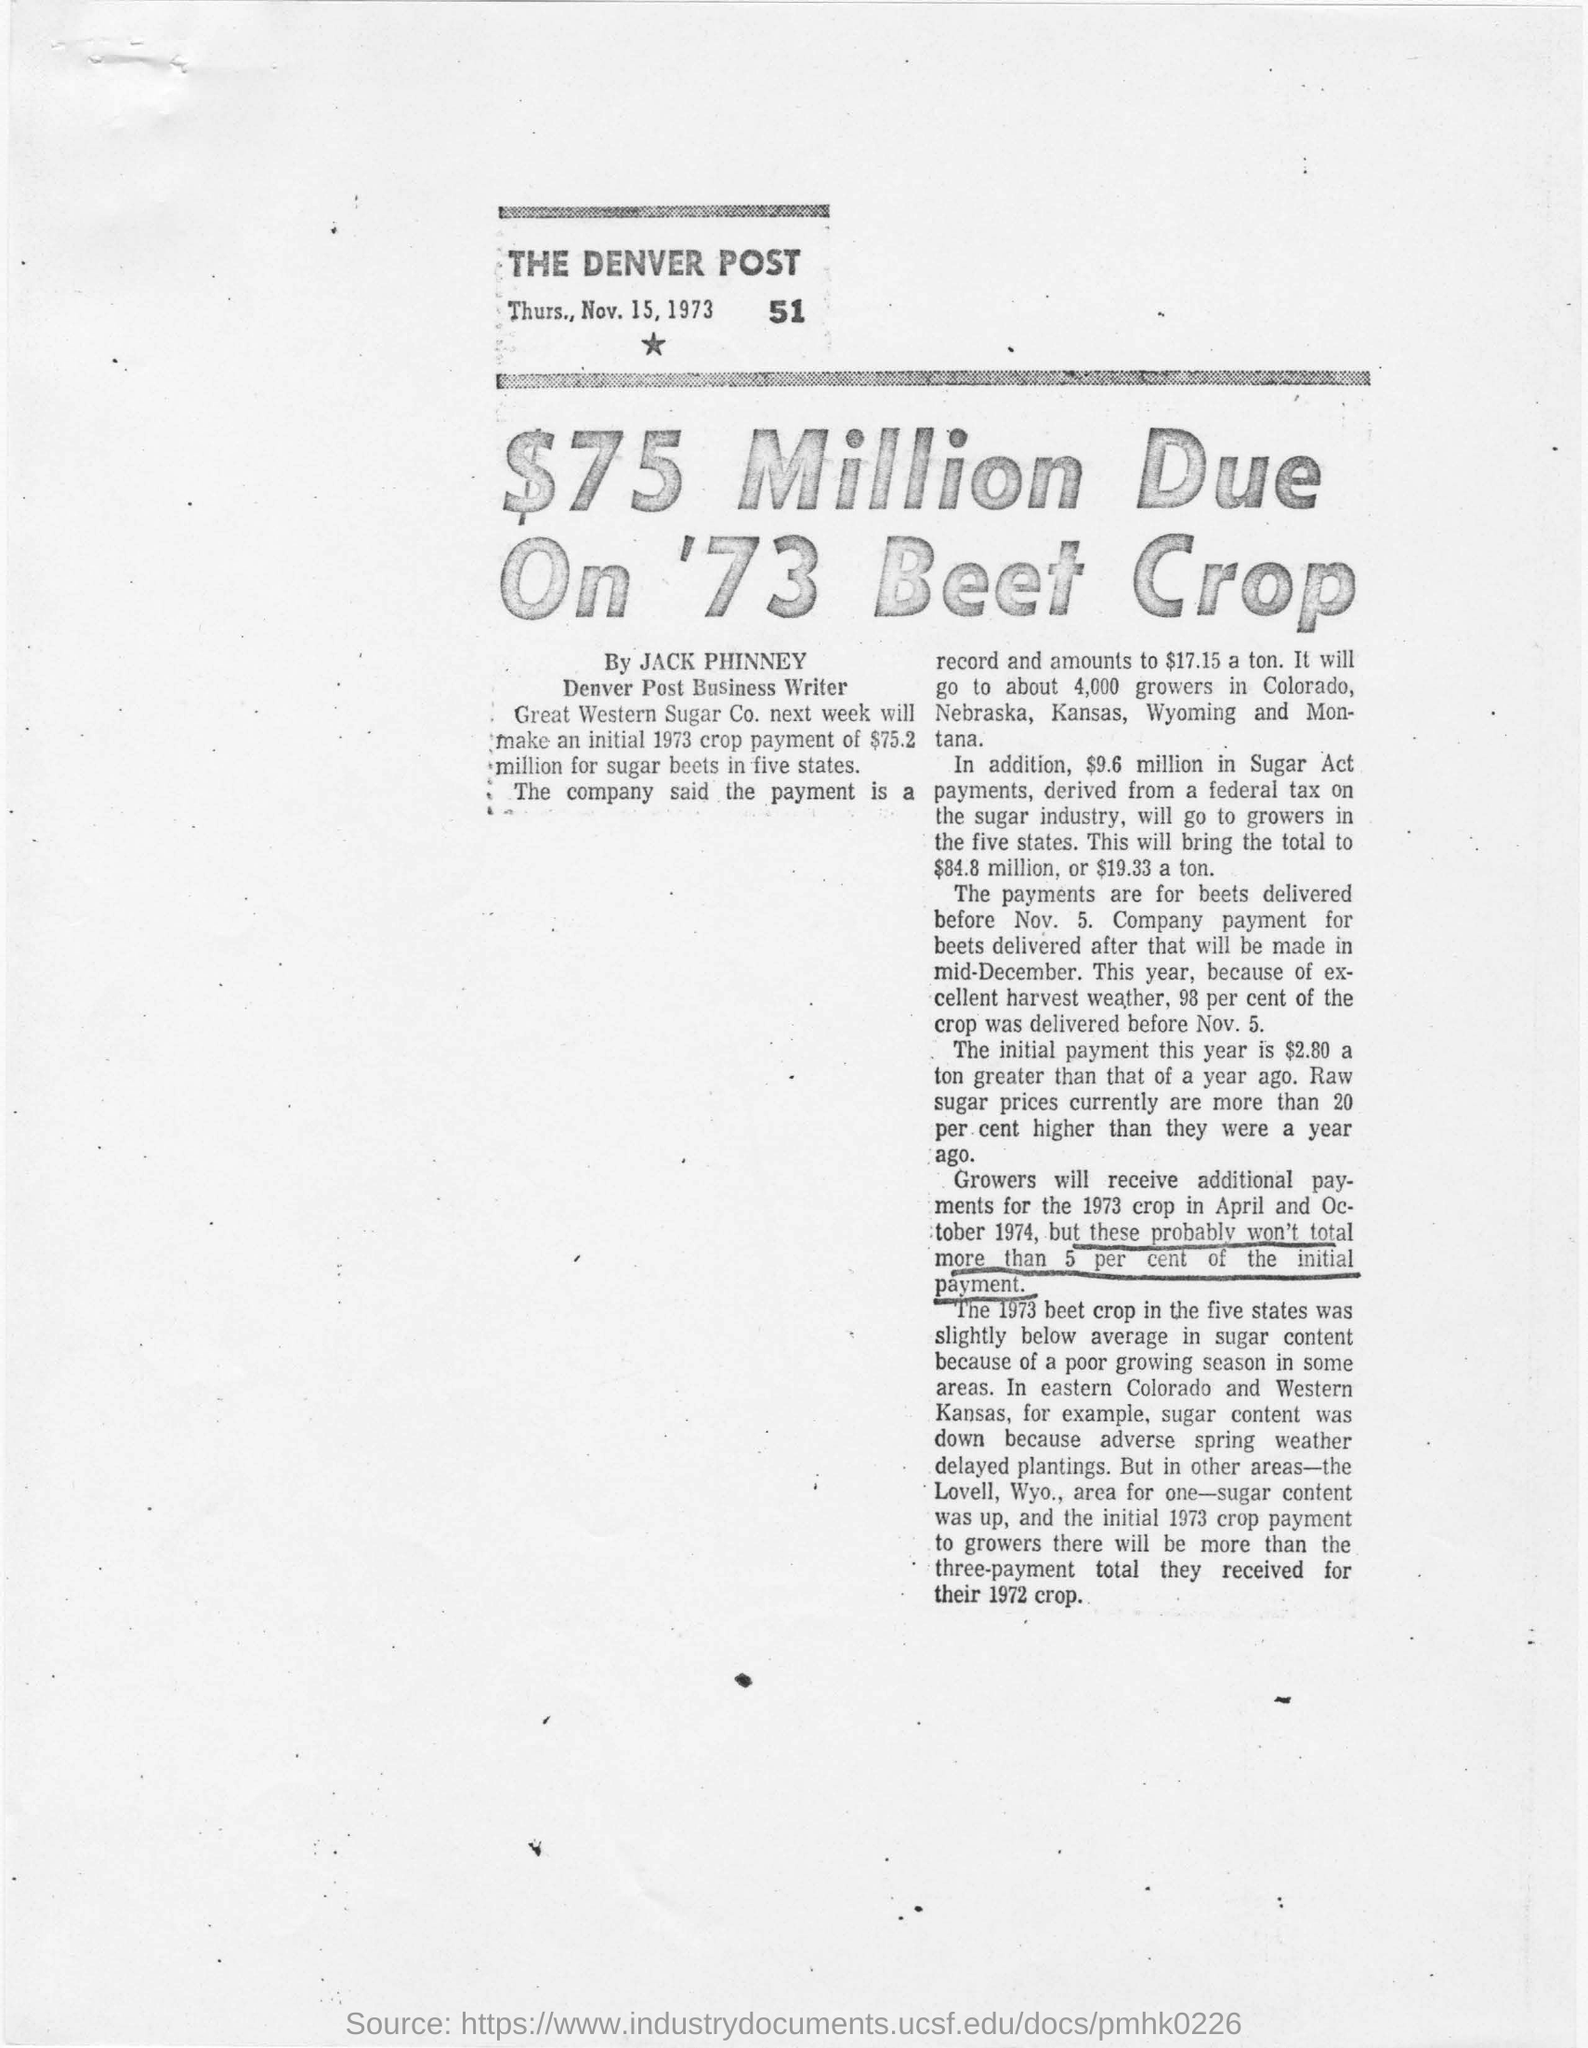Mention a couple of crucial points in this snapshot. This article was published on Thursday, November 15, 1973. Jack Phinney is a business writer for the Denver Post. This news paper is the Denver Post. The title of this page is "$75 Million due on '73 beet crop.". The Great Western Sugar Company is expected to make a initial crop payment of $75.2 million for sugar beets in five states in the next week. 